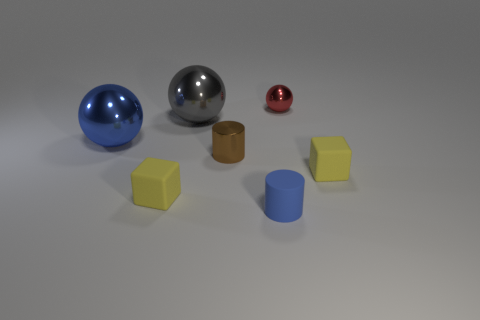Add 2 blue metal objects. How many objects exist? 9 Subtract all balls. How many objects are left? 4 Add 2 yellow blocks. How many yellow blocks exist? 4 Subtract 0 blue blocks. How many objects are left? 7 Subtract all large shiny things. Subtract all big blue matte things. How many objects are left? 5 Add 5 yellow things. How many yellow things are left? 7 